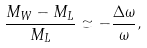Convert formula to latex. <formula><loc_0><loc_0><loc_500><loc_500>\frac { M _ { W } - M _ { L } } { M _ { L } } \simeq - \frac { \Delta \omega } { \omega } ,</formula> 